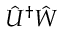Convert formula to latex. <formula><loc_0><loc_0><loc_500><loc_500>\hat { U } ^ { \dag } \hat { W }</formula> 